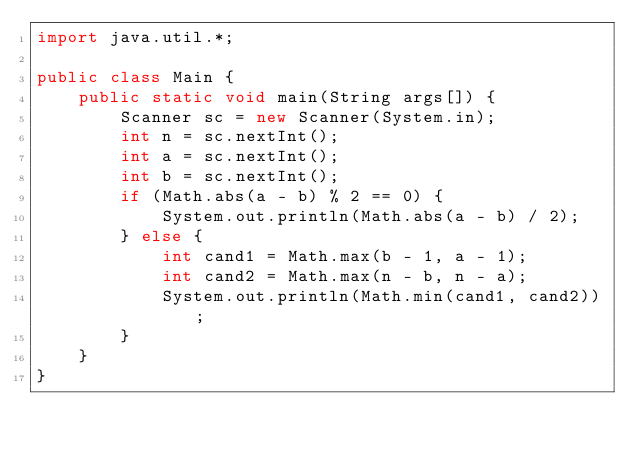<code> <loc_0><loc_0><loc_500><loc_500><_Java_>import java.util.*;

public class Main {
    public static void main(String args[]) {
        Scanner sc = new Scanner(System.in);
        int n = sc.nextInt();
        int a = sc.nextInt();
        int b = sc.nextInt();
        if (Math.abs(a - b) % 2 == 0) {
            System.out.println(Math.abs(a - b) / 2);
        } else {
            int cand1 = Math.max(b - 1, a - 1);
            int cand2 = Math.max(n - b, n - a);
            System.out.println(Math.min(cand1, cand2));
        }
    }
}</code> 